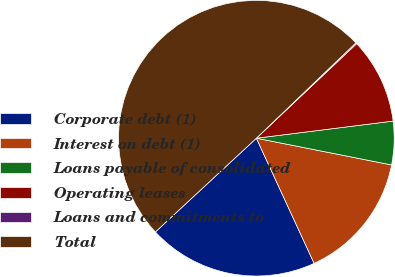Convert chart to OTSL. <chart><loc_0><loc_0><loc_500><loc_500><pie_chart><fcel>Corporate debt (1)<fcel>Interest on debt (1)<fcel>Loans payable of consolidated<fcel>Operating leases<fcel>Loans and commitments to<fcel>Total<nl><fcel>19.97%<fcel>15.01%<fcel>5.09%<fcel>10.05%<fcel>0.13%<fcel>49.74%<nl></chart> 